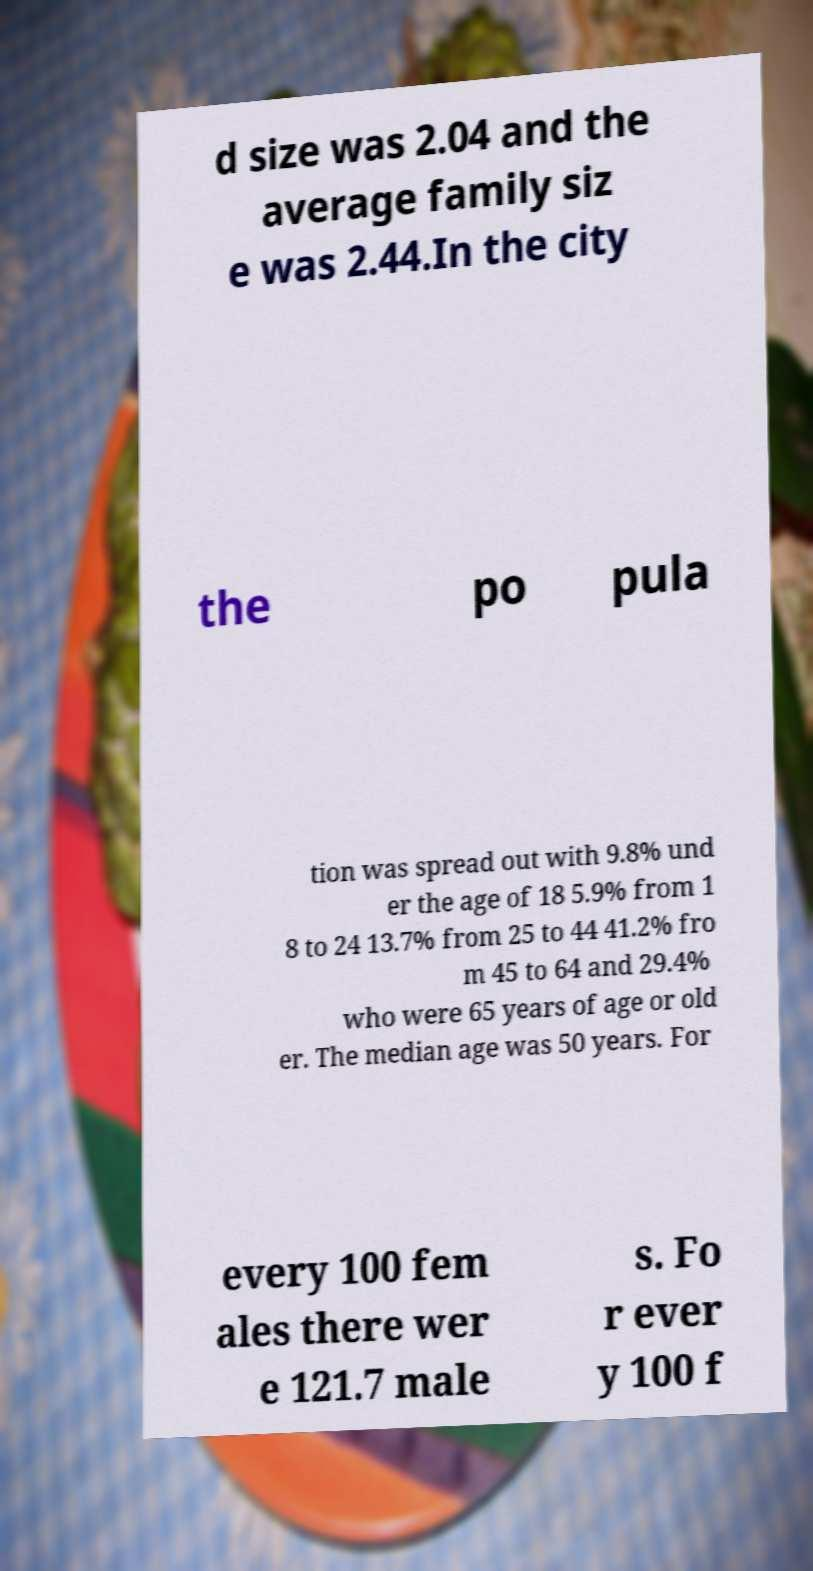What messages or text are displayed in this image? I need them in a readable, typed format. d size was 2.04 and the average family siz e was 2.44.In the city the po pula tion was spread out with 9.8% und er the age of 18 5.9% from 1 8 to 24 13.7% from 25 to 44 41.2% fro m 45 to 64 and 29.4% who were 65 years of age or old er. The median age was 50 years. For every 100 fem ales there wer e 121.7 male s. Fo r ever y 100 f 